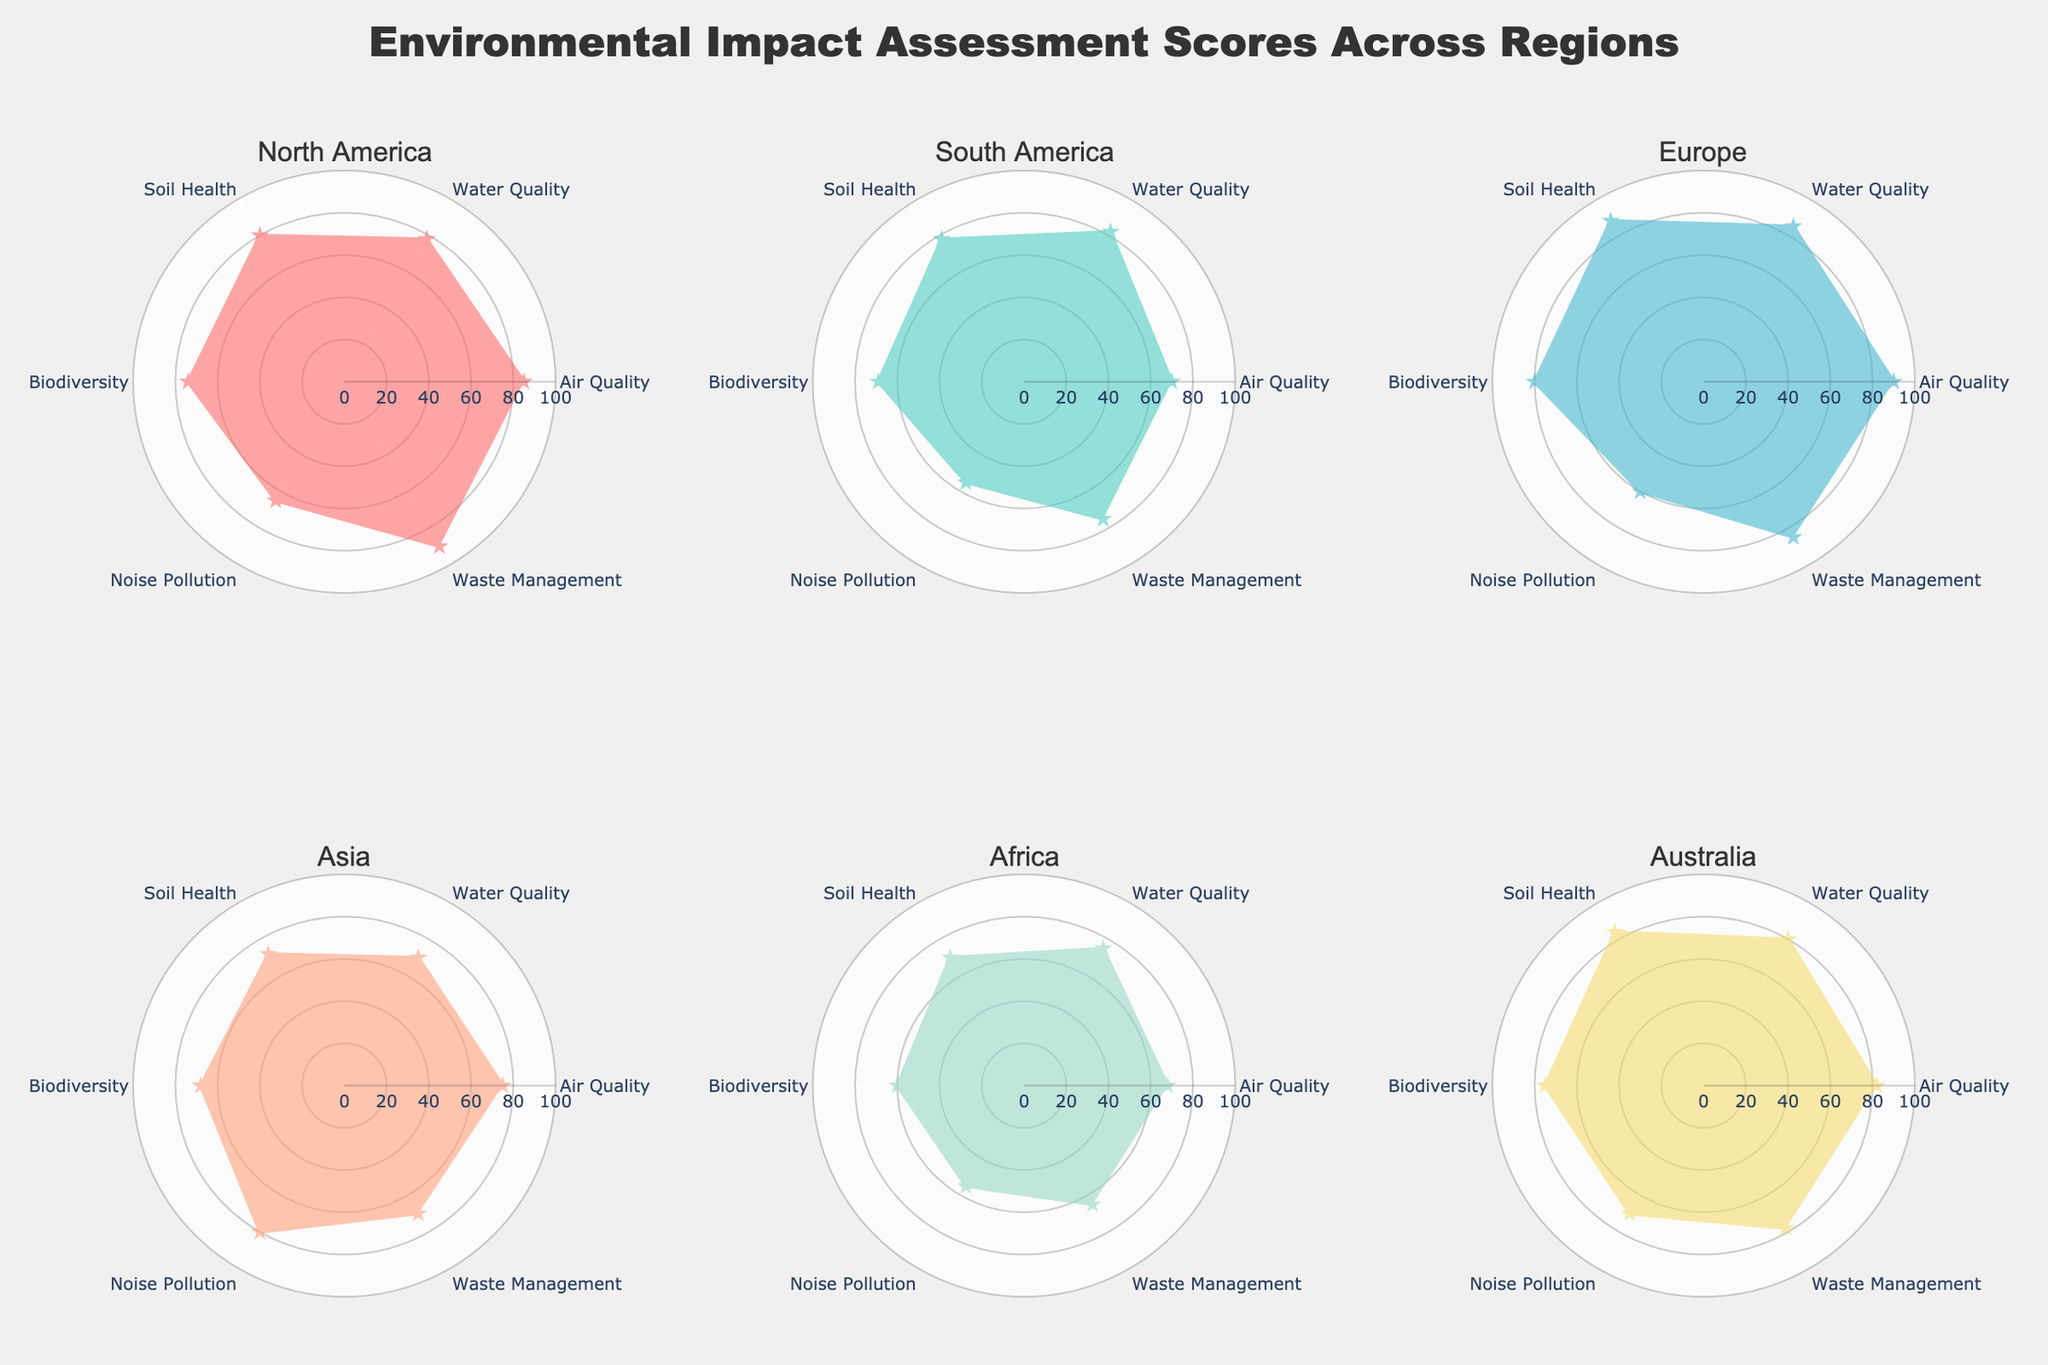What is the title of the figure? The title is shown at the top of the figure and is usually distinguished by a larger and bold font size compared to other text annotations.
Answer: Environmental Impact Assessment Scores Across Regions Which region has the highest Soil Health score? To find the region with the highest Soil Health score, compare the scores given for Soil Health across all regions.
Answer: Europe Compare the Air Quality scores between North America and Africa. Which has a higher score? Look at the Air Quality section for both North America and Africa and compare their scores directly.
Answer: North America Which environmental factor has the lowest score in South America? Identify all the scores for South America across the different environmental factors and find the smallest score.
Answer: Noise Pollution Calculate the average Environmental Impact Assessment score for Australia. Add the scores for all environmental factors in Australia and divide by the number of factors (6). (82 + 80 + 84 + 75 + 70 + 78) / 6 = 77.17
Answer: 77.17 Order the regions by their Air Quality scores from highest to lowest. Look at the Air Quality scores for each region and sort them in descending order.
Answer: Europe, North America, Australia, Asia, South America, Africa Which region shows the most balanced Environmental Impact Assessment scores across all factors? A balanced radar chart will have scores that are relatively similar across all measured factors. Look for the region with the least variation between scores.
Answer: Australia What is the range of Waste Management scores across all regions? Identify the highest and lowest Waste Management scores and calculate the difference between them. The highest is 90 (North America) and the lowest is 65 (Africa). 90 - 65 = 25
Answer: 25 Identify the region with the highest overall visual presence on the radar chart. The region with the highest overall visual presence will have the most area covered by its radar plot, indicated by generally high scores across all factors.
Answer: Europe 